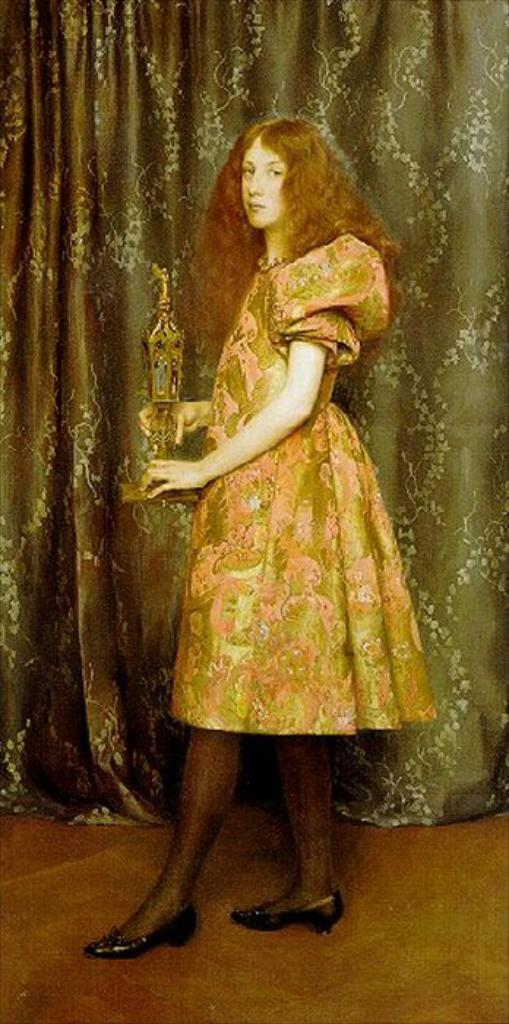What is the woman doing in the image? The woman is standing on a path in the image. What is the woman wearing? The woman is wearing a dress. What is the woman holding in the image? The woman is holding an award. What can be seen in the background of the image? There is a curtain with designs in the background of the image. What type of owl can be seen sitting on the woman's shoulder in the image? There is no owl present in the image; the woman is standing alone on the path. 